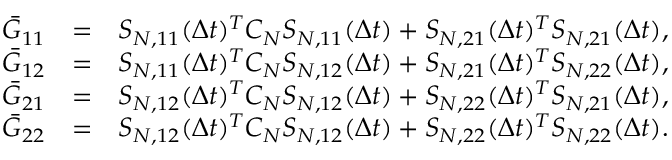Convert formula to latex. <formula><loc_0><loc_0><loc_500><loc_500>\begin{array} { r l r } { \bar { G } _ { 1 1 } } & { = } & { { S } _ { N , 1 1 } ( \Delta t ) ^ { T } C _ { N } { S } _ { N , 1 1 } ( \Delta t ) + { S } _ { N , 2 1 } ( \Delta t ) ^ { T } { S } _ { N , 2 1 } ( \Delta t ) , } \\ { \bar { G } _ { 1 2 } } & { = } & { { S } _ { N , 1 1 } ( \Delta t ) ^ { T } C _ { N } { S } _ { N , 1 2 } ( \Delta t ) + { S } _ { N , 2 1 } ( \Delta t ) ^ { T } { S } _ { N , 2 2 } ( \Delta t ) , } \\ { \bar { G } _ { 2 1 } } & { = } & { { S } _ { N , 1 2 } ( \Delta t ) ^ { T } C _ { N } { S } _ { N , 1 2 } ( \Delta t ) + { S } _ { N , 2 2 } ( \Delta t ) ^ { T } { S } _ { N , 2 1 } ( \Delta t ) , } \\ { \bar { G } _ { 2 2 } } & { = } & { { S } _ { N , 1 2 } ( \Delta t ) ^ { T } C _ { N } { S } _ { N , 1 2 } ( \Delta t ) + { S } _ { N , 2 2 } ( \Delta t ) ^ { T } { S } _ { N , 2 2 } ( \Delta t ) . } \end{array}</formula> 